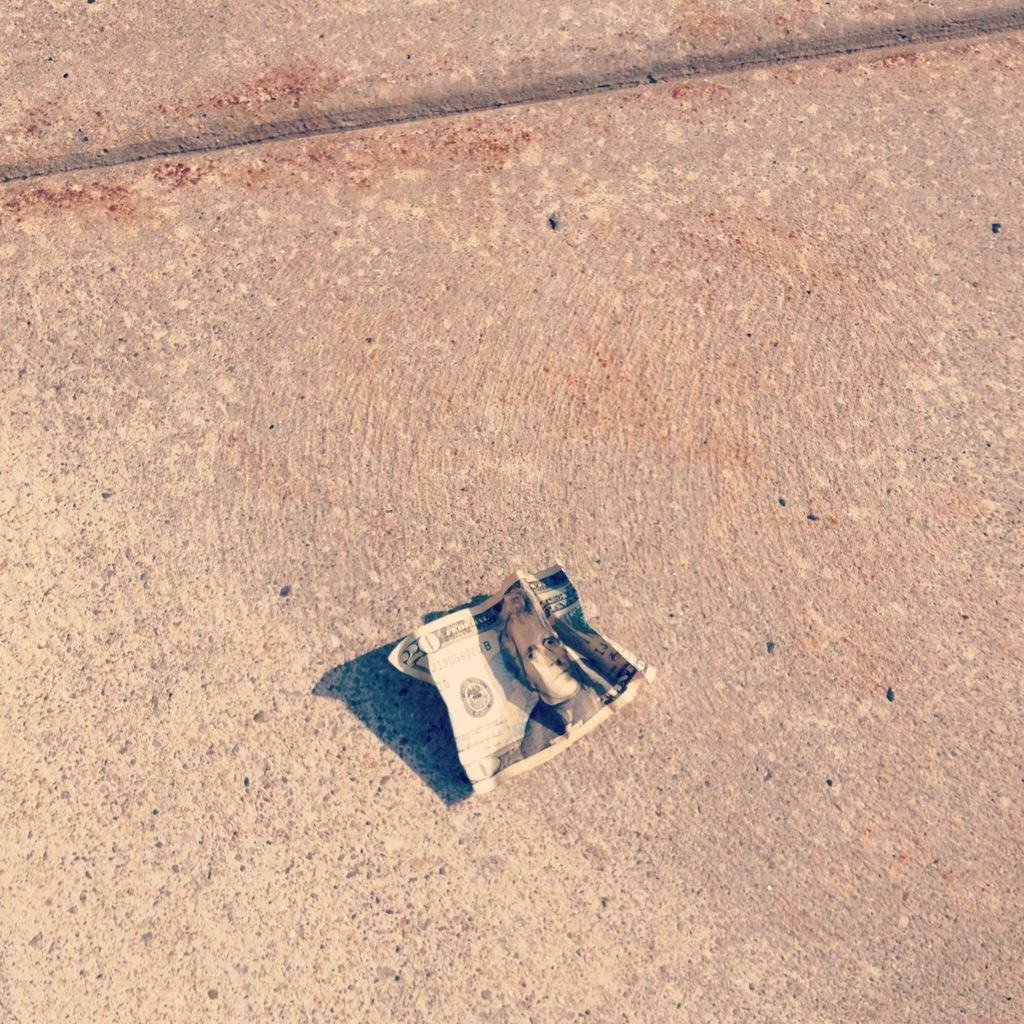What is present on the surface in the image? There is money in the image. Can you describe the position of the money in the image? The money is placed on a surface. What type of cake is being served on the hat in the image? There is no cake or hat present in the image; it only features money placed on a surface. 